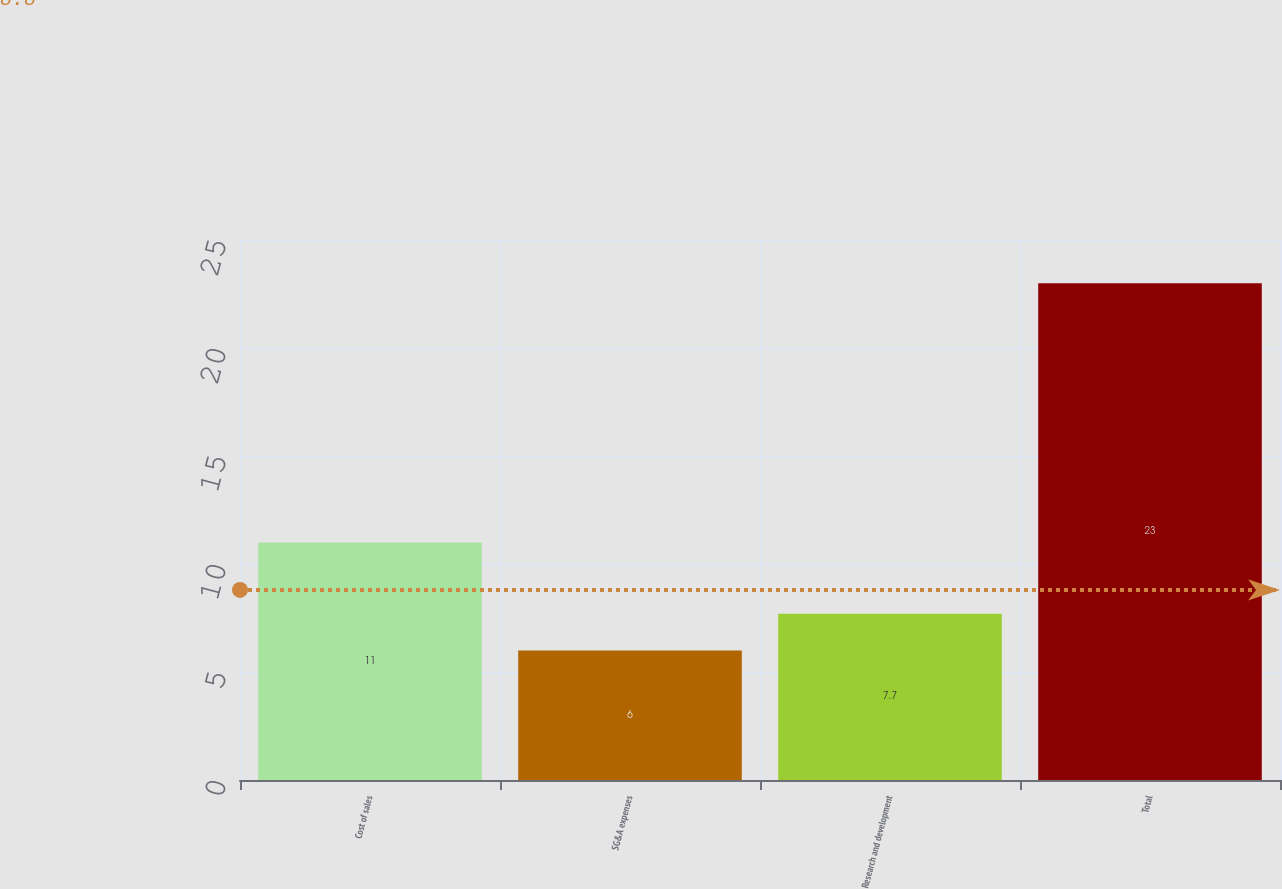<chart> <loc_0><loc_0><loc_500><loc_500><bar_chart><fcel>Cost of sales<fcel>SG&A expenses<fcel>Research and development<fcel>Total<nl><fcel>11<fcel>6<fcel>7.7<fcel>23<nl></chart> 